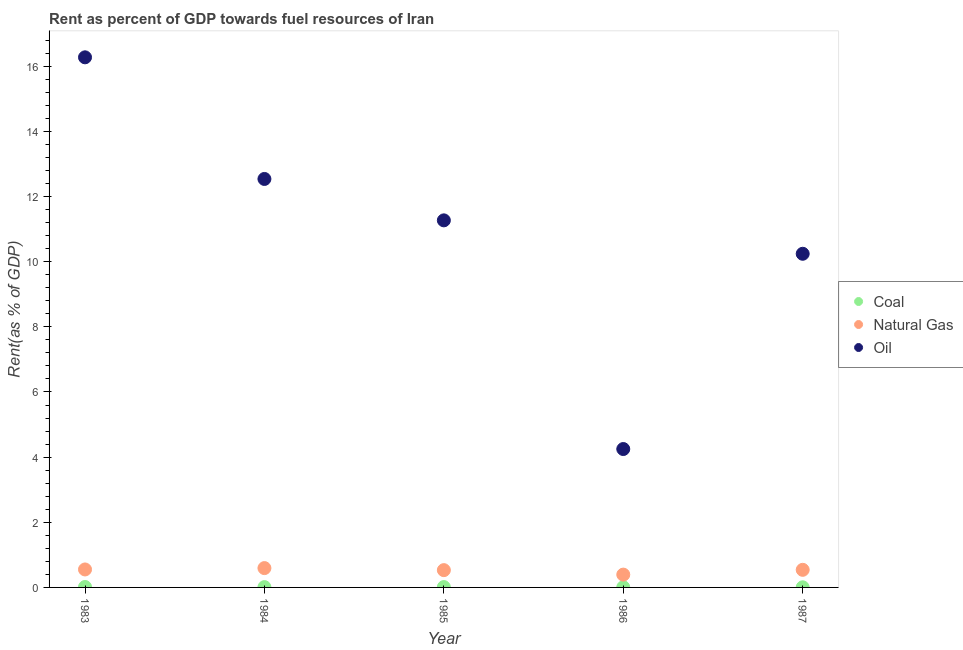How many different coloured dotlines are there?
Keep it short and to the point. 3. What is the rent towards natural gas in 1986?
Keep it short and to the point. 0.39. Across all years, what is the maximum rent towards coal?
Provide a short and direct response. 0.01. Across all years, what is the minimum rent towards coal?
Offer a very short reply. 0. In which year was the rent towards oil maximum?
Provide a short and direct response. 1983. What is the total rent towards natural gas in the graph?
Your answer should be compact. 2.61. What is the difference between the rent towards oil in 1985 and that in 1986?
Your answer should be very brief. 7.02. What is the difference between the rent towards oil in 1985 and the rent towards coal in 1986?
Give a very brief answer. 11.26. What is the average rent towards coal per year?
Provide a short and direct response. 0.01. In the year 1984, what is the difference between the rent towards oil and rent towards coal?
Provide a short and direct response. 12.53. What is the ratio of the rent towards natural gas in 1983 to that in 1987?
Provide a short and direct response. 1.02. Is the rent towards coal in 1986 less than that in 1987?
Give a very brief answer. No. Is the difference between the rent towards oil in 1984 and 1985 greater than the difference between the rent towards coal in 1984 and 1985?
Offer a terse response. Yes. What is the difference between the highest and the second highest rent towards oil?
Your answer should be very brief. 3.73. What is the difference between the highest and the lowest rent towards natural gas?
Offer a very short reply. 0.2. In how many years, is the rent towards coal greater than the average rent towards coal taken over all years?
Your answer should be compact. 3. Is it the case that in every year, the sum of the rent towards coal and rent towards natural gas is greater than the rent towards oil?
Offer a very short reply. No. Does the rent towards oil monotonically increase over the years?
Give a very brief answer. No. How many years are there in the graph?
Offer a very short reply. 5. Are the values on the major ticks of Y-axis written in scientific E-notation?
Offer a terse response. No. Does the graph contain grids?
Keep it short and to the point. No. How many legend labels are there?
Ensure brevity in your answer.  3. What is the title of the graph?
Keep it short and to the point. Rent as percent of GDP towards fuel resources of Iran. What is the label or title of the Y-axis?
Make the answer very short. Rent(as % of GDP). What is the Rent(as % of GDP) of Coal in 1983?
Your response must be concise. 0.01. What is the Rent(as % of GDP) in Natural Gas in 1983?
Your answer should be very brief. 0.55. What is the Rent(as % of GDP) in Oil in 1983?
Offer a very short reply. 16.27. What is the Rent(as % of GDP) of Coal in 1984?
Offer a very short reply. 0.01. What is the Rent(as % of GDP) of Natural Gas in 1984?
Make the answer very short. 0.59. What is the Rent(as % of GDP) of Oil in 1984?
Your answer should be very brief. 12.54. What is the Rent(as % of GDP) of Coal in 1985?
Your answer should be compact. 0.01. What is the Rent(as % of GDP) of Natural Gas in 1985?
Your response must be concise. 0.53. What is the Rent(as % of GDP) in Oil in 1985?
Your answer should be compact. 11.27. What is the Rent(as % of GDP) of Coal in 1986?
Your response must be concise. 0.01. What is the Rent(as % of GDP) in Natural Gas in 1986?
Provide a succinct answer. 0.39. What is the Rent(as % of GDP) of Oil in 1986?
Give a very brief answer. 4.25. What is the Rent(as % of GDP) in Coal in 1987?
Keep it short and to the point. 0. What is the Rent(as % of GDP) in Natural Gas in 1987?
Offer a very short reply. 0.54. What is the Rent(as % of GDP) of Oil in 1987?
Give a very brief answer. 10.24. Across all years, what is the maximum Rent(as % of GDP) of Coal?
Keep it short and to the point. 0.01. Across all years, what is the maximum Rent(as % of GDP) in Natural Gas?
Give a very brief answer. 0.59. Across all years, what is the maximum Rent(as % of GDP) in Oil?
Provide a succinct answer. 16.27. Across all years, what is the minimum Rent(as % of GDP) of Coal?
Ensure brevity in your answer.  0. Across all years, what is the minimum Rent(as % of GDP) in Natural Gas?
Give a very brief answer. 0.39. Across all years, what is the minimum Rent(as % of GDP) in Oil?
Keep it short and to the point. 4.25. What is the total Rent(as % of GDP) of Coal in the graph?
Keep it short and to the point. 0.04. What is the total Rent(as % of GDP) in Natural Gas in the graph?
Make the answer very short. 2.61. What is the total Rent(as % of GDP) in Oil in the graph?
Ensure brevity in your answer.  54.57. What is the difference between the Rent(as % of GDP) of Coal in 1983 and that in 1984?
Provide a short and direct response. 0. What is the difference between the Rent(as % of GDP) of Natural Gas in 1983 and that in 1984?
Your answer should be compact. -0.04. What is the difference between the Rent(as % of GDP) of Oil in 1983 and that in 1984?
Ensure brevity in your answer.  3.73. What is the difference between the Rent(as % of GDP) of Coal in 1983 and that in 1985?
Provide a succinct answer. 0. What is the difference between the Rent(as % of GDP) in Natural Gas in 1983 and that in 1985?
Your answer should be compact. 0.02. What is the difference between the Rent(as % of GDP) of Oil in 1983 and that in 1985?
Your answer should be compact. 5. What is the difference between the Rent(as % of GDP) in Coal in 1983 and that in 1986?
Provide a succinct answer. 0.01. What is the difference between the Rent(as % of GDP) in Natural Gas in 1983 and that in 1986?
Provide a succinct answer. 0.16. What is the difference between the Rent(as % of GDP) of Oil in 1983 and that in 1986?
Offer a terse response. 12.02. What is the difference between the Rent(as % of GDP) in Coal in 1983 and that in 1987?
Make the answer very short. 0.01. What is the difference between the Rent(as % of GDP) of Natural Gas in 1983 and that in 1987?
Give a very brief answer. 0.01. What is the difference between the Rent(as % of GDP) of Oil in 1983 and that in 1987?
Your answer should be very brief. 6.03. What is the difference between the Rent(as % of GDP) in Coal in 1984 and that in 1985?
Provide a succinct answer. -0. What is the difference between the Rent(as % of GDP) in Natural Gas in 1984 and that in 1985?
Make the answer very short. 0.06. What is the difference between the Rent(as % of GDP) of Oil in 1984 and that in 1985?
Your answer should be very brief. 1.27. What is the difference between the Rent(as % of GDP) in Coal in 1984 and that in 1986?
Offer a very short reply. 0. What is the difference between the Rent(as % of GDP) of Natural Gas in 1984 and that in 1986?
Provide a succinct answer. 0.2. What is the difference between the Rent(as % of GDP) in Oil in 1984 and that in 1986?
Offer a terse response. 8.29. What is the difference between the Rent(as % of GDP) in Coal in 1984 and that in 1987?
Offer a terse response. 0.01. What is the difference between the Rent(as % of GDP) in Natural Gas in 1984 and that in 1987?
Offer a very short reply. 0.05. What is the difference between the Rent(as % of GDP) of Oil in 1984 and that in 1987?
Your response must be concise. 2.3. What is the difference between the Rent(as % of GDP) in Coal in 1985 and that in 1986?
Give a very brief answer. 0.01. What is the difference between the Rent(as % of GDP) in Natural Gas in 1985 and that in 1986?
Your answer should be very brief. 0.14. What is the difference between the Rent(as % of GDP) of Oil in 1985 and that in 1986?
Provide a succinct answer. 7.02. What is the difference between the Rent(as % of GDP) in Coal in 1985 and that in 1987?
Your answer should be compact. 0.01. What is the difference between the Rent(as % of GDP) in Natural Gas in 1985 and that in 1987?
Offer a terse response. -0.01. What is the difference between the Rent(as % of GDP) of Oil in 1985 and that in 1987?
Make the answer very short. 1.03. What is the difference between the Rent(as % of GDP) of Coal in 1986 and that in 1987?
Give a very brief answer. 0. What is the difference between the Rent(as % of GDP) of Natural Gas in 1986 and that in 1987?
Keep it short and to the point. -0.15. What is the difference between the Rent(as % of GDP) of Oil in 1986 and that in 1987?
Give a very brief answer. -5.99. What is the difference between the Rent(as % of GDP) of Coal in 1983 and the Rent(as % of GDP) of Natural Gas in 1984?
Provide a succinct answer. -0.58. What is the difference between the Rent(as % of GDP) of Coal in 1983 and the Rent(as % of GDP) of Oil in 1984?
Offer a very short reply. -12.53. What is the difference between the Rent(as % of GDP) in Natural Gas in 1983 and the Rent(as % of GDP) in Oil in 1984?
Provide a short and direct response. -11.99. What is the difference between the Rent(as % of GDP) of Coal in 1983 and the Rent(as % of GDP) of Natural Gas in 1985?
Your answer should be very brief. -0.52. What is the difference between the Rent(as % of GDP) of Coal in 1983 and the Rent(as % of GDP) of Oil in 1985?
Make the answer very short. -11.26. What is the difference between the Rent(as % of GDP) in Natural Gas in 1983 and the Rent(as % of GDP) in Oil in 1985?
Your answer should be compact. -10.72. What is the difference between the Rent(as % of GDP) in Coal in 1983 and the Rent(as % of GDP) in Natural Gas in 1986?
Your response must be concise. -0.38. What is the difference between the Rent(as % of GDP) of Coal in 1983 and the Rent(as % of GDP) of Oil in 1986?
Offer a terse response. -4.24. What is the difference between the Rent(as % of GDP) of Natural Gas in 1983 and the Rent(as % of GDP) of Oil in 1986?
Your answer should be very brief. -3.7. What is the difference between the Rent(as % of GDP) in Coal in 1983 and the Rent(as % of GDP) in Natural Gas in 1987?
Your answer should be compact. -0.53. What is the difference between the Rent(as % of GDP) in Coal in 1983 and the Rent(as % of GDP) in Oil in 1987?
Keep it short and to the point. -10.23. What is the difference between the Rent(as % of GDP) in Natural Gas in 1983 and the Rent(as % of GDP) in Oil in 1987?
Make the answer very short. -9.69. What is the difference between the Rent(as % of GDP) of Coal in 1984 and the Rent(as % of GDP) of Natural Gas in 1985?
Provide a succinct answer. -0.52. What is the difference between the Rent(as % of GDP) in Coal in 1984 and the Rent(as % of GDP) in Oil in 1985?
Offer a terse response. -11.26. What is the difference between the Rent(as % of GDP) in Natural Gas in 1984 and the Rent(as % of GDP) in Oil in 1985?
Provide a short and direct response. -10.68. What is the difference between the Rent(as % of GDP) in Coal in 1984 and the Rent(as % of GDP) in Natural Gas in 1986?
Make the answer very short. -0.38. What is the difference between the Rent(as % of GDP) in Coal in 1984 and the Rent(as % of GDP) in Oil in 1986?
Your response must be concise. -4.24. What is the difference between the Rent(as % of GDP) in Natural Gas in 1984 and the Rent(as % of GDP) in Oil in 1986?
Make the answer very short. -3.66. What is the difference between the Rent(as % of GDP) in Coal in 1984 and the Rent(as % of GDP) in Natural Gas in 1987?
Your response must be concise. -0.53. What is the difference between the Rent(as % of GDP) in Coal in 1984 and the Rent(as % of GDP) in Oil in 1987?
Keep it short and to the point. -10.23. What is the difference between the Rent(as % of GDP) of Natural Gas in 1984 and the Rent(as % of GDP) of Oil in 1987?
Give a very brief answer. -9.65. What is the difference between the Rent(as % of GDP) in Coal in 1985 and the Rent(as % of GDP) in Natural Gas in 1986?
Your response must be concise. -0.38. What is the difference between the Rent(as % of GDP) of Coal in 1985 and the Rent(as % of GDP) of Oil in 1986?
Your answer should be compact. -4.24. What is the difference between the Rent(as % of GDP) of Natural Gas in 1985 and the Rent(as % of GDP) of Oil in 1986?
Keep it short and to the point. -3.72. What is the difference between the Rent(as % of GDP) of Coal in 1985 and the Rent(as % of GDP) of Natural Gas in 1987?
Your response must be concise. -0.53. What is the difference between the Rent(as % of GDP) of Coal in 1985 and the Rent(as % of GDP) of Oil in 1987?
Your answer should be compact. -10.23. What is the difference between the Rent(as % of GDP) of Natural Gas in 1985 and the Rent(as % of GDP) of Oil in 1987?
Your response must be concise. -9.71. What is the difference between the Rent(as % of GDP) in Coal in 1986 and the Rent(as % of GDP) in Natural Gas in 1987?
Offer a very short reply. -0.54. What is the difference between the Rent(as % of GDP) in Coal in 1986 and the Rent(as % of GDP) in Oil in 1987?
Provide a succinct answer. -10.24. What is the difference between the Rent(as % of GDP) in Natural Gas in 1986 and the Rent(as % of GDP) in Oil in 1987?
Your answer should be very brief. -9.85. What is the average Rent(as % of GDP) of Coal per year?
Your answer should be very brief. 0.01. What is the average Rent(as % of GDP) of Natural Gas per year?
Your answer should be compact. 0.52. What is the average Rent(as % of GDP) of Oil per year?
Make the answer very short. 10.91. In the year 1983, what is the difference between the Rent(as % of GDP) of Coal and Rent(as % of GDP) of Natural Gas?
Keep it short and to the point. -0.54. In the year 1983, what is the difference between the Rent(as % of GDP) in Coal and Rent(as % of GDP) in Oil?
Your response must be concise. -16.26. In the year 1983, what is the difference between the Rent(as % of GDP) in Natural Gas and Rent(as % of GDP) in Oil?
Make the answer very short. -15.72. In the year 1984, what is the difference between the Rent(as % of GDP) in Coal and Rent(as % of GDP) in Natural Gas?
Your response must be concise. -0.58. In the year 1984, what is the difference between the Rent(as % of GDP) in Coal and Rent(as % of GDP) in Oil?
Give a very brief answer. -12.53. In the year 1984, what is the difference between the Rent(as % of GDP) in Natural Gas and Rent(as % of GDP) in Oil?
Your answer should be very brief. -11.95. In the year 1985, what is the difference between the Rent(as % of GDP) in Coal and Rent(as % of GDP) in Natural Gas?
Provide a short and direct response. -0.52. In the year 1985, what is the difference between the Rent(as % of GDP) in Coal and Rent(as % of GDP) in Oil?
Offer a terse response. -11.26. In the year 1985, what is the difference between the Rent(as % of GDP) in Natural Gas and Rent(as % of GDP) in Oil?
Ensure brevity in your answer.  -10.74. In the year 1986, what is the difference between the Rent(as % of GDP) of Coal and Rent(as % of GDP) of Natural Gas?
Provide a short and direct response. -0.39. In the year 1986, what is the difference between the Rent(as % of GDP) in Coal and Rent(as % of GDP) in Oil?
Provide a short and direct response. -4.24. In the year 1986, what is the difference between the Rent(as % of GDP) of Natural Gas and Rent(as % of GDP) of Oil?
Provide a succinct answer. -3.86. In the year 1987, what is the difference between the Rent(as % of GDP) of Coal and Rent(as % of GDP) of Natural Gas?
Offer a very short reply. -0.54. In the year 1987, what is the difference between the Rent(as % of GDP) of Coal and Rent(as % of GDP) of Oil?
Provide a succinct answer. -10.24. In the year 1987, what is the difference between the Rent(as % of GDP) of Natural Gas and Rent(as % of GDP) of Oil?
Provide a short and direct response. -9.7. What is the ratio of the Rent(as % of GDP) in Coal in 1983 to that in 1984?
Make the answer very short. 1.4. What is the ratio of the Rent(as % of GDP) in Natural Gas in 1983 to that in 1984?
Your answer should be very brief. 0.93. What is the ratio of the Rent(as % of GDP) of Oil in 1983 to that in 1984?
Provide a succinct answer. 1.3. What is the ratio of the Rent(as % of GDP) in Coal in 1983 to that in 1985?
Offer a very short reply. 1.22. What is the ratio of the Rent(as % of GDP) of Natural Gas in 1983 to that in 1985?
Give a very brief answer. 1.04. What is the ratio of the Rent(as % of GDP) in Oil in 1983 to that in 1985?
Provide a short and direct response. 1.44. What is the ratio of the Rent(as % of GDP) in Coal in 1983 to that in 1986?
Your response must be concise. 2.45. What is the ratio of the Rent(as % of GDP) of Natural Gas in 1983 to that in 1986?
Give a very brief answer. 1.4. What is the ratio of the Rent(as % of GDP) of Oil in 1983 to that in 1986?
Your answer should be very brief. 3.83. What is the ratio of the Rent(as % of GDP) in Coal in 1983 to that in 1987?
Provide a succinct answer. 3.76. What is the ratio of the Rent(as % of GDP) in Natural Gas in 1983 to that in 1987?
Provide a succinct answer. 1.02. What is the ratio of the Rent(as % of GDP) in Oil in 1983 to that in 1987?
Provide a succinct answer. 1.59. What is the ratio of the Rent(as % of GDP) of Coal in 1984 to that in 1985?
Make the answer very short. 0.88. What is the ratio of the Rent(as % of GDP) in Natural Gas in 1984 to that in 1985?
Give a very brief answer. 1.12. What is the ratio of the Rent(as % of GDP) of Oil in 1984 to that in 1985?
Your answer should be compact. 1.11. What is the ratio of the Rent(as % of GDP) in Coal in 1984 to that in 1986?
Keep it short and to the point. 1.76. What is the ratio of the Rent(as % of GDP) of Natural Gas in 1984 to that in 1986?
Offer a terse response. 1.51. What is the ratio of the Rent(as % of GDP) in Oil in 1984 to that in 1986?
Give a very brief answer. 2.95. What is the ratio of the Rent(as % of GDP) of Coal in 1984 to that in 1987?
Keep it short and to the point. 2.7. What is the ratio of the Rent(as % of GDP) of Natural Gas in 1984 to that in 1987?
Your answer should be compact. 1.1. What is the ratio of the Rent(as % of GDP) in Oil in 1984 to that in 1987?
Provide a short and direct response. 1.22. What is the ratio of the Rent(as % of GDP) of Coal in 1985 to that in 1986?
Offer a very short reply. 2. What is the ratio of the Rent(as % of GDP) of Natural Gas in 1985 to that in 1986?
Offer a terse response. 1.35. What is the ratio of the Rent(as % of GDP) of Oil in 1985 to that in 1986?
Give a very brief answer. 2.65. What is the ratio of the Rent(as % of GDP) of Coal in 1985 to that in 1987?
Make the answer very short. 3.08. What is the ratio of the Rent(as % of GDP) of Natural Gas in 1985 to that in 1987?
Provide a succinct answer. 0.98. What is the ratio of the Rent(as % of GDP) of Oil in 1985 to that in 1987?
Give a very brief answer. 1.1. What is the ratio of the Rent(as % of GDP) of Coal in 1986 to that in 1987?
Your answer should be very brief. 1.54. What is the ratio of the Rent(as % of GDP) in Natural Gas in 1986 to that in 1987?
Your answer should be very brief. 0.73. What is the ratio of the Rent(as % of GDP) of Oil in 1986 to that in 1987?
Ensure brevity in your answer.  0.41. What is the difference between the highest and the second highest Rent(as % of GDP) of Coal?
Provide a succinct answer. 0. What is the difference between the highest and the second highest Rent(as % of GDP) of Natural Gas?
Ensure brevity in your answer.  0.04. What is the difference between the highest and the second highest Rent(as % of GDP) of Oil?
Your answer should be compact. 3.73. What is the difference between the highest and the lowest Rent(as % of GDP) in Coal?
Make the answer very short. 0.01. What is the difference between the highest and the lowest Rent(as % of GDP) of Oil?
Your answer should be very brief. 12.02. 